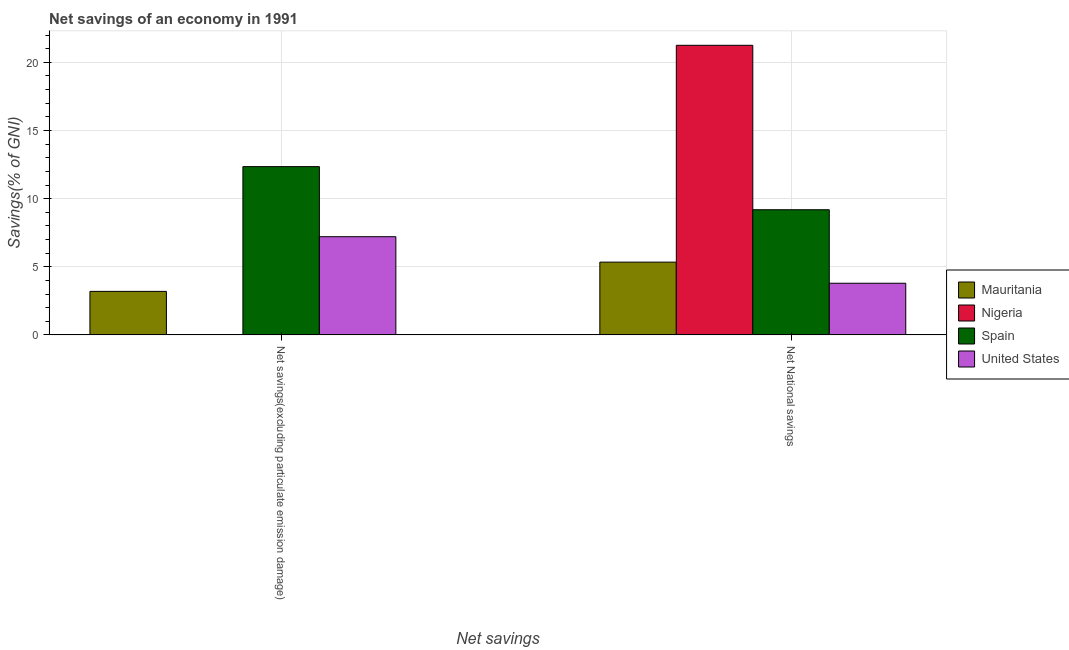How many groups of bars are there?
Provide a short and direct response. 2. What is the label of the 1st group of bars from the left?
Offer a terse response. Net savings(excluding particulate emission damage). What is the net national savings in Spain?
Your answer should be very brief. 9.18. Across all countries, what is the maximum net savings(excluding particulate emission damage)?
Provide a short and direct response. 12.35. Across all countries, what is the minimum net savings(excluding particulate emission damage)?
Offer a terse response. 0. In which country was the net savings(excluding particulate emission damage) maximum?
Provide a succinct answer. Spain. What is the total net national savings in the graph?
Offer a terse response. 39.57. What is the difference between the net savings(excluding particulate emission damage) in Mauritania and that in Spain?
Keep it short and to the point. -9.16. What is the difference between the net national savings in Nigeria and the net savings(excluding particulate emission damage) in Spain?
Offer a very short reply. 8.9. What is the average net savings(excluding particulate emission damage) per country?
Give a very brief answer. 5.69. What is the difference between the net savings(excluding particulate emission damage) and net national savings in Mauritania?
Keep it short and to the point. -2.15. In how many countries, is the net national savings greater than 12 %?
Offer a very short reply. 1. What is the ratio of the net national savings in United States to that in Spain?
Offer a very short reply. 0.41. Is the net national savings in Spain less than that in Mauritania?
Ensure brevity in your answer.  No. What is the difference between two consecutive major ticks on the Y-axis?
Your answer should be very brief. 5. Are the values on the major ticks of Y-axis written in scientific E-notation?
Provide a succinct answer. No. Does the graph contain grids?
Your answer should be compact. Yes. Where does the legend appear in the graph?
Give a very brief answer. Center right. How many legend labels are there?
Your answer should be compact. 4. What is the title of the graph?
Provide a succinct answer. Net savings of an economy in 1991. Does "Central African Republic" appear as one of the legend labels in the graph?
Offer a very short reply. No. What is the label or title of the X-axis?
Ensure brevity in your answer.  Net savings. What is the label or title of the Y-axis?
Keep it short and to the point. Savings(% of GNI). What is the Savings(% of GNI) in Mauritania in Net savings(excluding particulate emission damage)?
Your answer should be very brief. 3.19. What is the Savings(% of GNI) in Nigeria in Net savings(excluding particulate emission damage)?
Ensure brevity in your answer.  0. What is the Savings(% of GNI) in Spain in Net savings(excluding particulate emission damage)?
Offer a terse response. 12.35. What is the Savings(% of GNI) of United States in Net savings(excluding particulate emission damage)?
Ensure brevity in your answer.  7.21. What is the Savings(% of GNI) in Mauritania in Net National savings?
Give a very brief answer. 5.34. What is the Savings(% of GNI) of Nigeria in Net National savings?
Provide a short and direct response. 21.25. What is the Savings(% of GNI) in Spain in Net National savings?
Keep it short and to the point. 9.18. What is the Savings(% of GNI) in United States in Net National savings?
Offer a terse response. 3.79. Across all Net savings, what is the maximum Savings(% of GNI) of Mauritania?
Ensure brevity in your answer.  5.34. Across all Net savings, what is the maximum Savings(% of GNI) in Nigeria?
Keep it short and to the point. 21.25. Across all Net savings, what is the maximum Savings(% of GNI) in Spain?
Keep it short and to the point. 12.35. Across all Net savings, what is the maximum Savings(% of GNI) in United States?
Offer a very short reply. 7.21. Across all Net savings, what is the minimum Savings(% of GNI) of Mauritania?
Ensure brevity in your answer.  3.19. Across all Net savings, what is the minimum Savings(% of GNI) of Spain?
Your answer should be compact. 9.18. Across all Net savings, what is the minimum Savings(% of GNI) of United States?
Make the answer very short. 3.79. What is the total Savings(% of GNI) of Mauritania in the graph?
Your answer should be compact. 8.53. What is the total Savings(% of GNI) of Nigeria in the graph?
Offer a terse response. 21.25. What is the total Savings(% of GNI) of Spain in the graph?
Ensure brevity in your answer.  21.53. What is the total Savings(% of GNI) in United States in the graph?
Make the answer very short. 11. What is the difference between the Savings(% of GNI) in Mauritania in Net savings(excluding particulate emission damage) and that in Net National savings?
Offer a terse response. -2.15. What is the difference between the Savings(% of GNI) of Spain in Net savings(excluding particulate emission damage) and that in Net National savings?
Offer a very short reply. 3.16. What is the difference between the Savings(% of GNI) in United States in Net savings(excluding particulate emission damage) and that in Net National savings?
Provide a short and direct response. 3.41. What is the difference between the Savings(% of GNI) of Mauritania in Net savings(excluding particulate emission damage) and the Savings(% of GNI) of Nigeria in Net National savings?
Your answer should be very brief. -18.06. What is the difference between the Savings(% of GNI) of Mauritania in Net savings(excluding particulate emission damage) and the Savings(% of GNI) of Spain in Net National savings?
Make the answer very short. -5.99. What is the difference between the Savings(% of GNI) of Mauritania in Net savings(excluding particulate emission damage) and the Savings(% of GNI) of United States in Net National savings?
Offer a terse response. -0.6. What is the difference between the Savings(% of GNI) of Spain in Net savings(excluding particulate emission damage) and the Savings(% of GNI) of United States in Net National savings?
Offer a very short reply. 8.56. What is the average Savings(% of GNI) of Mauritania per Net savings?
Keep it short and to the point. 4.27. What is the average Savings(% of GNI) of Nigeria per Net savings?
Offer a very short reply. 10.63. What is the average Savings(% of GNI) in Spain per Net savings?
Offer a very short reply. 10.77. What is the average Savings(% of GNI) of United States per Net savings?
Ensure brevity in your answer.  5.5. What is the difference between the Savings(% of GNI) in Mauritania and Savings(% of GNI) in Spain in Net savings(excluding particulate emission damage)?
Keep it short and to the point. -9.16. What is the difference between the Savings(% of GNI) in Mauritania and Savings(% of GNI) in United States in Net savings(excluding particulate emission damage)?
Your answer should be very brief. -4.01. What is the difference between the Savings(% of GNI) in Spain and Savings(% of GNI) in United States in Net savings(excluding particulate emission damage)?
Provide a short and direct response. 5.14. What is the difference between the Savings(% of GNI) of Mauritania and Savings(% of GNI) of Nigeria in Net National savings?
Offer a terse response. -15.91. What is the difference between the Savings(% of GNI) in Mauritania and Savings(% of GNI) in Spain in Net National savings?
Your answer should be compact. -3.84. What is the difference between the Savings(% of GNI) in Mauritania and Savings(% of GNI) in United States in Net National savings?
Offer a very short reply. 1.55. What is the difference between the Savings(% of GNI) in Nigeria and Savings(% of GNI) in Spain in Net National savings?
Your response must be concise. 12.07. What is the difference between the Savings(% of GNI) of Nigeria and Savings(% of GNI) of United States in Net National savings?
Make the answer very short. 17.46. What is the difference between the Savings(% of GNI) of Spain and Savings(% of GNI) of United States in Net National savings?
Offer a very short reply. 5.39. What is the ratio of the Savings(% of GNI) of Mauritania in Net savings(excluding particulate emission damage) to that in Net National savings?
Provide a short and direct response. 0.6. What is the ratio of the Savings(% of GNI) in Spain in Net savings(excluding particulate emission damage) to that in Net National savings?
Give a very brief answer. 1.34. What is the ratio of the Savings(% of GNI) of United States in Net savings(excluding particulate emission damage) to that in Net National savings?
Your response must be concise. 1.9. What is the difference between the highest and the second highest Savings(% of GNI) in Mauritania?
Keep it short and to the point. 2.15. What is the difference between the highest and the second highest Savings(% of GNI) in Spain?
Your answer should be compact. 3.16. What is the difference between the highest and the second highest Savings(% of GNI) of United States?
Your answer should be compact. 3.41. What is the difference between the highest and the lowest Savings(% of GNI) in Mauritania?
Offer a terse response. 2.15. What is the difference between the highest and the lowest Savings(% of GNI) of Nigeria?
Your answer should be very brief. 21.25. What is the difference between the highest and the lowest Savings(% of GNI) in Spain?
Keep it short and to the point. 3.16. What is the difference between the highest and the lowest Savings(% of GNI) in United States?
Give a very brief answer. 3.41. 